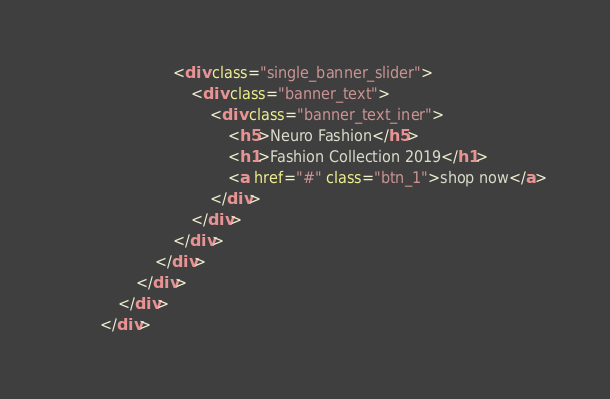<code> <loc_0><loc_0><loc_500><loc_500><_HTML_>                        <div class="single_banner_slider">
                            <div class="banner_text">
                                <div class="banner_text_iner">
                                    <h5>Neuro Fashion</h5>
                                    <h1>Fashion Collection 2019</h1>
                                    <a href="#" class="btn_1">shop now</a>
                                </div>
                            </div>
                        </div>
                    </div>
                </div>
            </div>
        </div></code> 